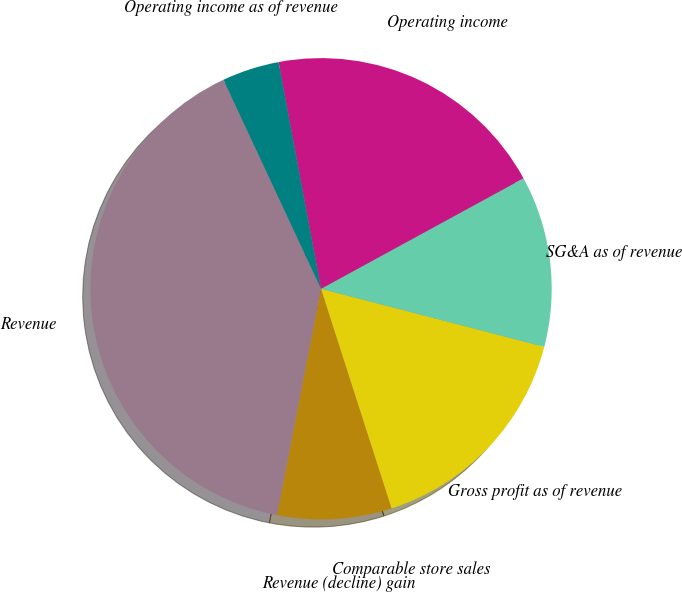Convert chart to OTSL. <chart><loc_0><loc_0><loc_500><loc_500><pie_chart><fcel>Revenue<fcel>Revenue (decline) gain<fcel>Comparable store sales<fcel>Gross profit as of revenue<fcel>SG&A as of revenue<fcel>Operating income<fcel>Operating income as of revenue<nl><fcel>40.0%<fcel>8.0%<fcel>0.0%<fcel>16.0%<fcel>12.0%<fcel>20.0%<fcel>4.0%<nl></chart> 